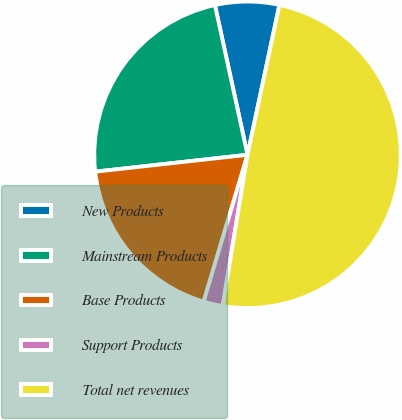Convert chart. <chart><loc_0><loc_0><loc_500><loc_500><pie_chart><fcel>New Products<fcel>Mainstream Products<fcel>Base Products<fcel>Support Products<fcel>Total net revenues<nl><fcel>6.75%<fcel>23.34%<fcel>18.62%<fcel>2.03%<fcel>49.25%<nl></chart> 